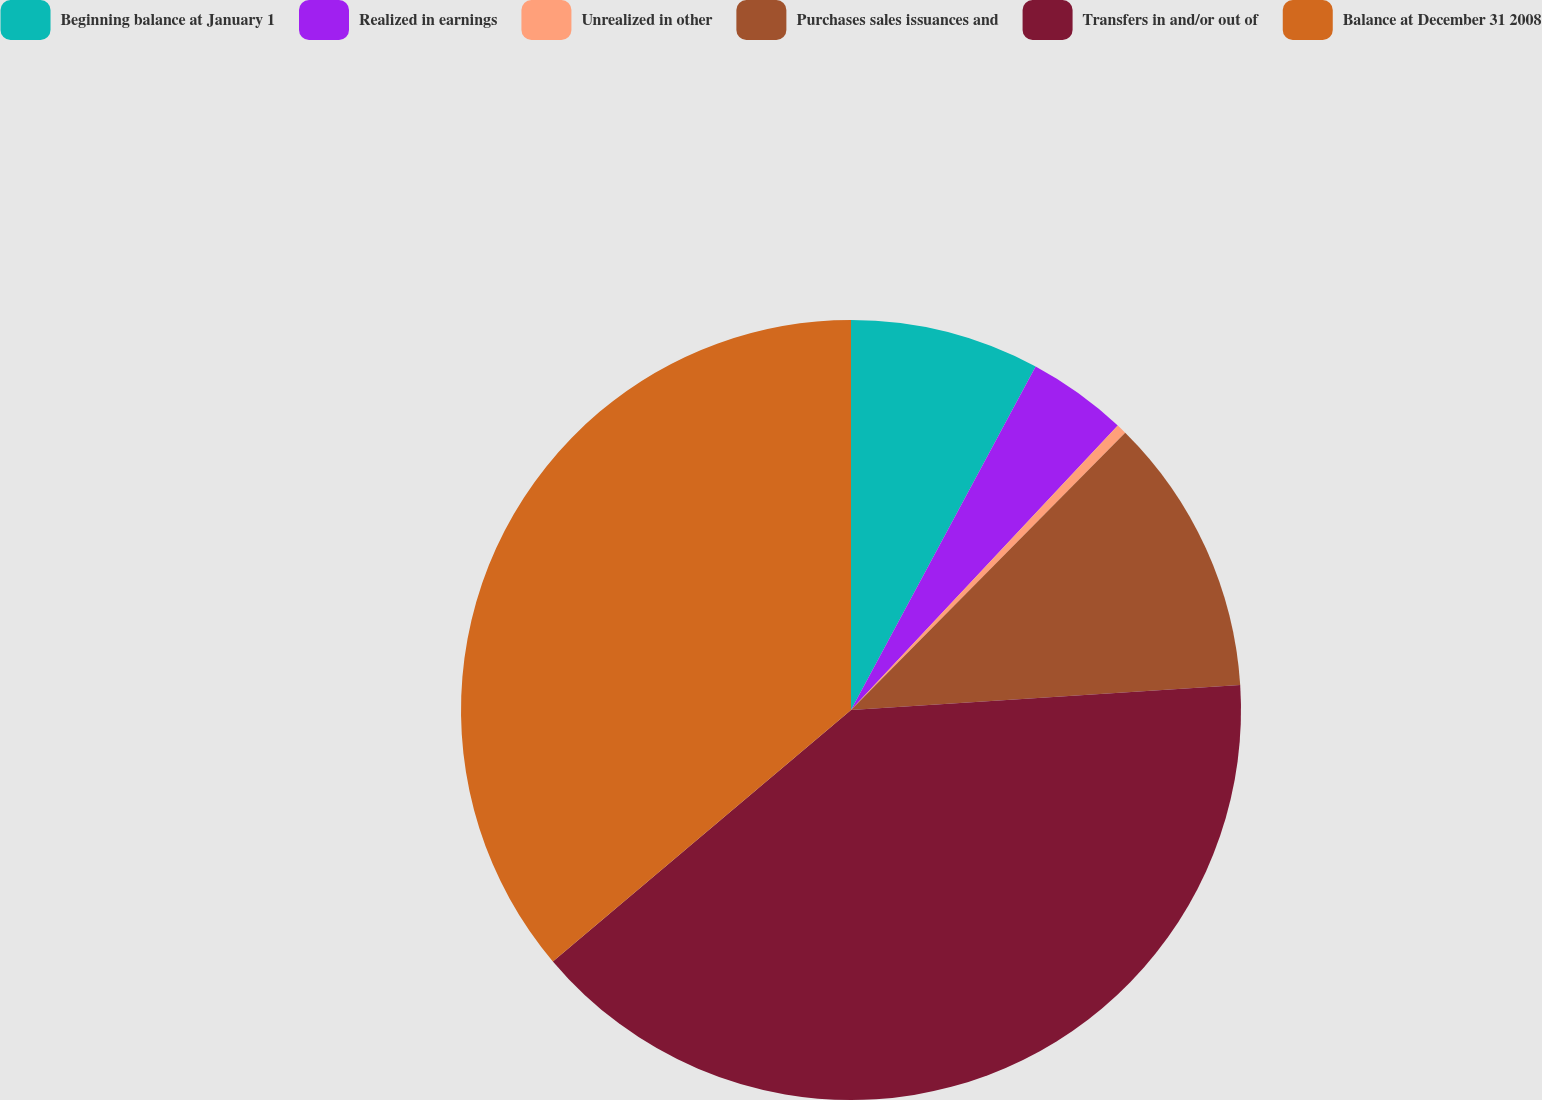<chart> <loc_0><loc_0><loc_500><loc_500><pie_chart><fcel>Beginning balance at January 1<fcel>Realized in earnings<fcel>Unrealized in other<fcel>Purchases sales issuances and<fcel>Transfers in and/or out of<fcel>Balance at December 31 2008<nl><fcel>7.85%<fcel>4.14%<fcel>0.42%<fcel>11.57%<fcel>39.87%<fcel>36.15%<nl></chart> 